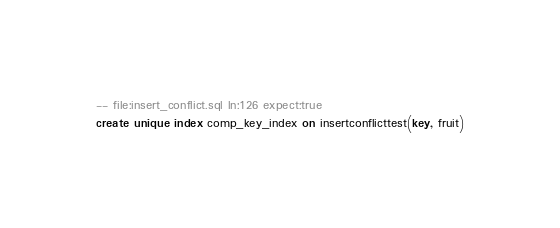<code> <loc_0><loc_0><loc_500><loc_500><_SQL_>-- file:insert_conflict.sql ln:126 expect:true
create unique index comp_key_index on insertconflicttest(key, fruit)
</code> 